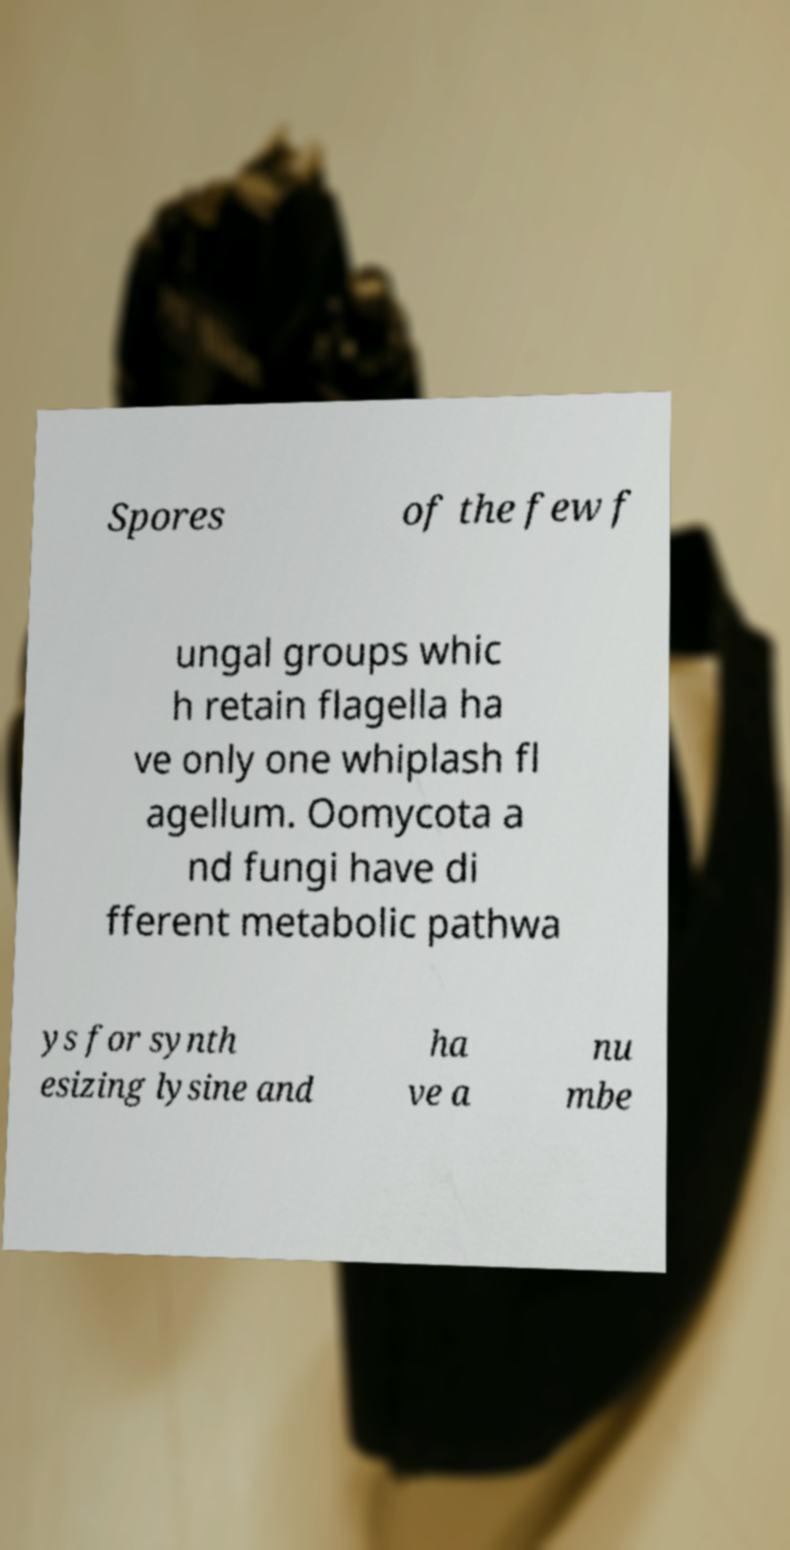I need the written content from this picture converted into text. Can you do that? Spores of the few f ungal groups whic h retain flagella ha ve only one whiplash fl agellum. Oomycota a nd fungi have di fferent metabolic pathwa ys for synth esizing lysine and ha ve a nu mbe 